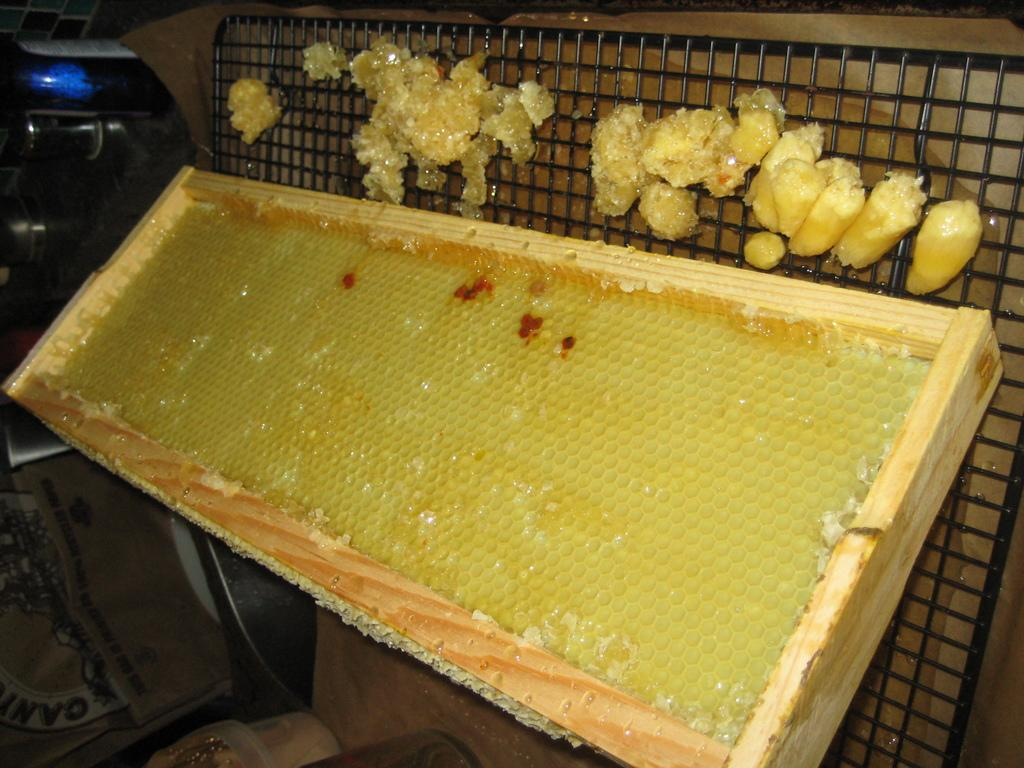What is located in the center of the image? There is a wooden frame and a honeycomb in the center of the image. What type of material is used for the frame? The frame is made of wood. What can be seen on the wooden frame? A honeycomb is visible on the wooden frame. What is present in the background of the image? There are objects on metal rods and other objects visible in the background of the image. What type of horn can be seen in the image? There is no horn present in the image. What scientific experiment is being conducted in the image? There is no scientific experiment depicted in the image. 